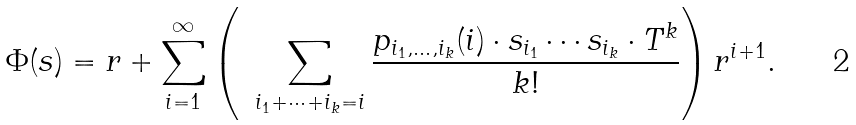Convert formula to latex. <formula><loc_0><loc_0><loc_500><loc_500>\Phi ( s ) = r + \sum _ { i = 1 } ^ { \infty } \left ( \ \, \sum _ { i _ { 1 } + \cdots + i _ { k } = i } \frac { p _ { i _ { 1 } , \dots , i _ { k } } ( i ) \cdot s _ { i _ { 1 } } \cdots s _ { i _ { k } } \cdot T ^ { k } } { k ! } \right ) r ^ { i + 1 } .</formula> 